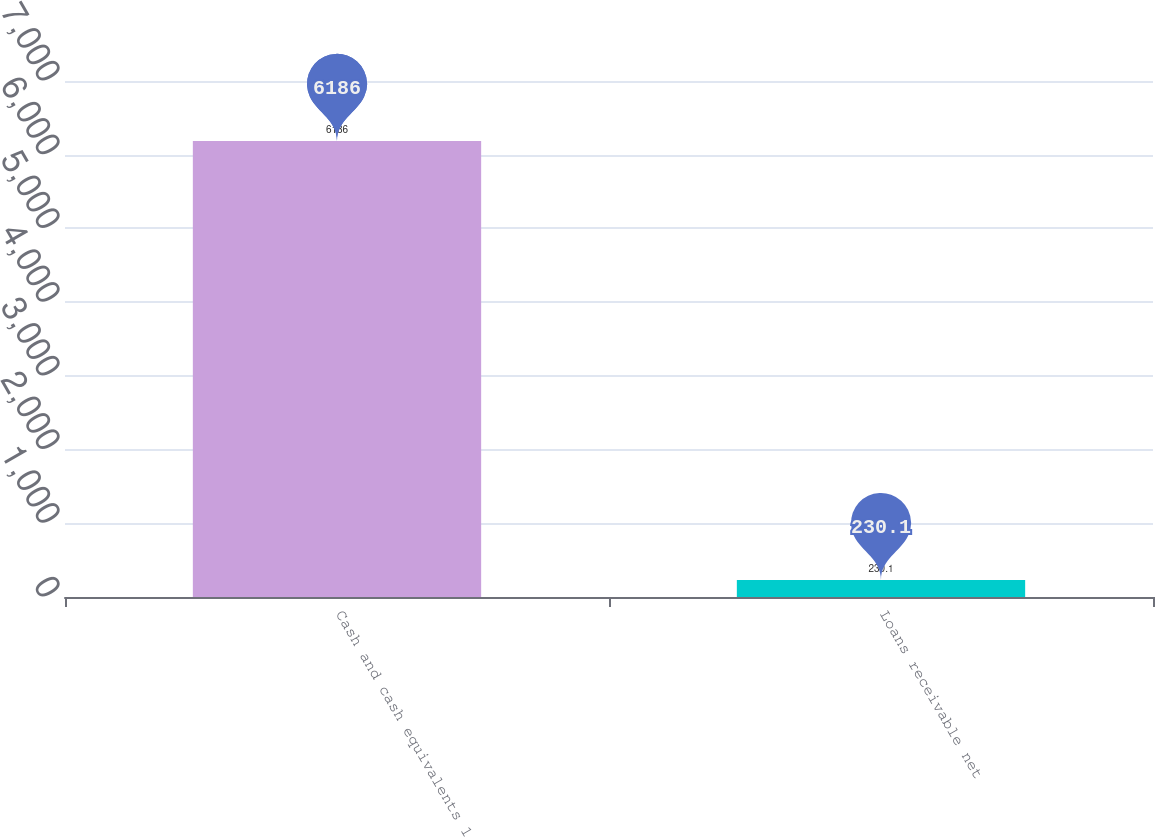Convert chart to OTSL. <chart><loc_0><loc_0><loc_500><loc_500><bar_chart><fcel>Cash and cash equivalents 1<fcel>Loans receivable net<nl><fcel>6186<fcel>230.1<nl></chart> 